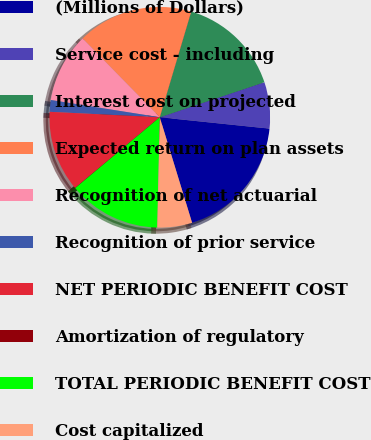Convert chart to OTSL. <chart><loc_0><loc_0><loc_500><loc_500><pie_chart><fcel>(Millions of Dollars)<fcel>Service cost - including<fcel>Interest cost on projected<fcel>Expected return on plan assets<fcel>Recognition of net actuarial<fcel>Recognition of prior service<fcel>NET PERIODIC BENEFIT COST<fcel>Amortization of regulatory<fcel>TOTAL PERIODIC BENEFIT COST<fcel>Cost capitalized<nl><fcel>18.63%<fcel>6.79%<fcel>15.25%<fcel>16.94%<fcel>10.17%<fcel>1.71%<fcel>11.86%<fcel>0.02%<fcel>13.55%<fcel>5.09%<nl></chart> 